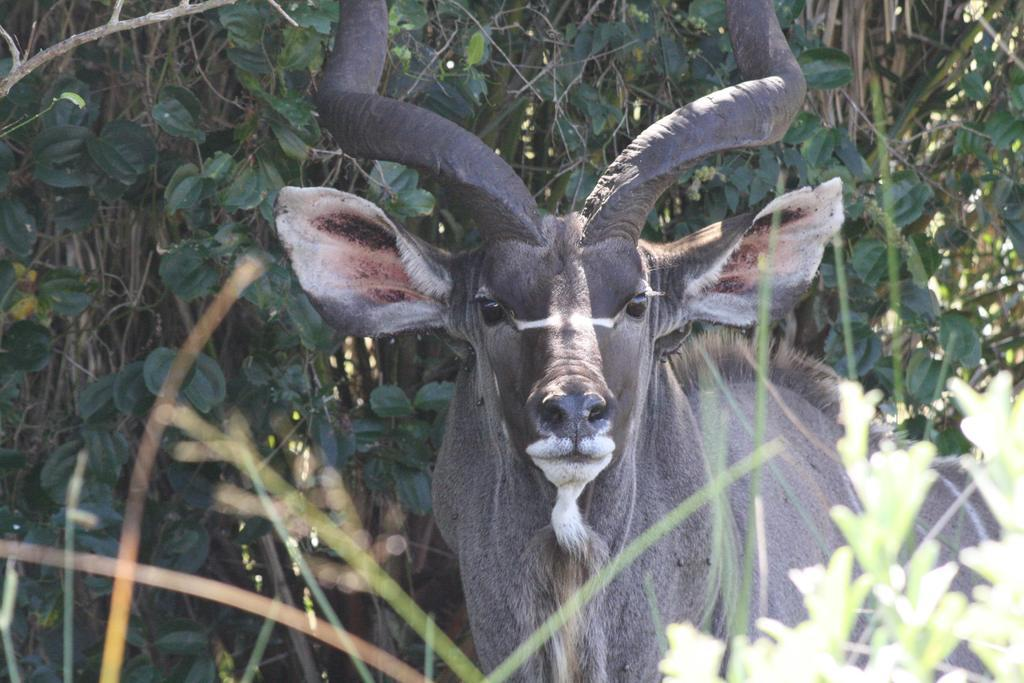What type of creature is in the image? There is an animal in the image. Can you describe the coloring of the animal? The animal has brown and cream coloring. What can be seen in the background of the image? There are plants in the background of the image. What is the color of the plants? The plants are green in color. Where is the aunt sitting with the tray in the image? There is no aunt or tray present in the image. 